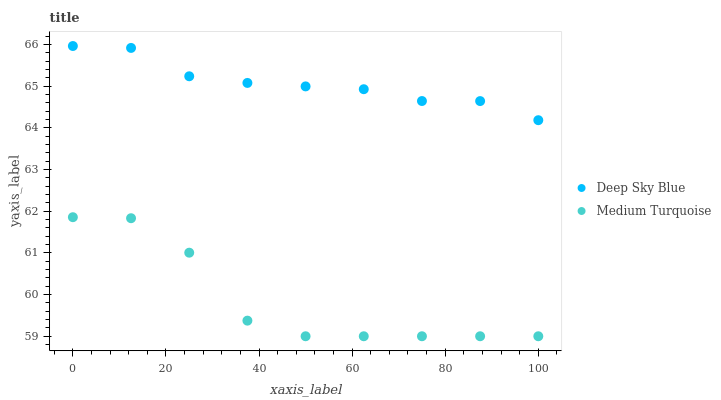Does Medium Turquoise have the minimum area under the curve?
Answer yes or no. Yes. Does Deep Sky Blue have the maximum area under the curve?
Answer yes or no. Yes. Does Deep Sky Blue have the minimum area under the curve?
Answer yes or no. No. Is Deep Sky Blue the smoothest?
Answer yes or no. Yes. Is Medium Turquoise the roughest?
Answer yes or no. Yes. Is Deep Sky Blue the roughest?
Answer yes or no. No. Does Medium Turquoise have the lowest value?
Answer yes or no. Yes. Does Deep Sky Blue have the lowest value?
Answer yes or no. No. Does Deep Sky Blue have the highest value?
Answer yes or no. Yes. Is Medium Turquoise less than Deep Sky Blue?
Answer yes or no. Yes. Is Deep Sky Blue greater than Medium Turquoise?
Answer yes or no. Yes. Does Medium Turquoise intersect Deep Sky Blue?
Answer yes or no. No. 